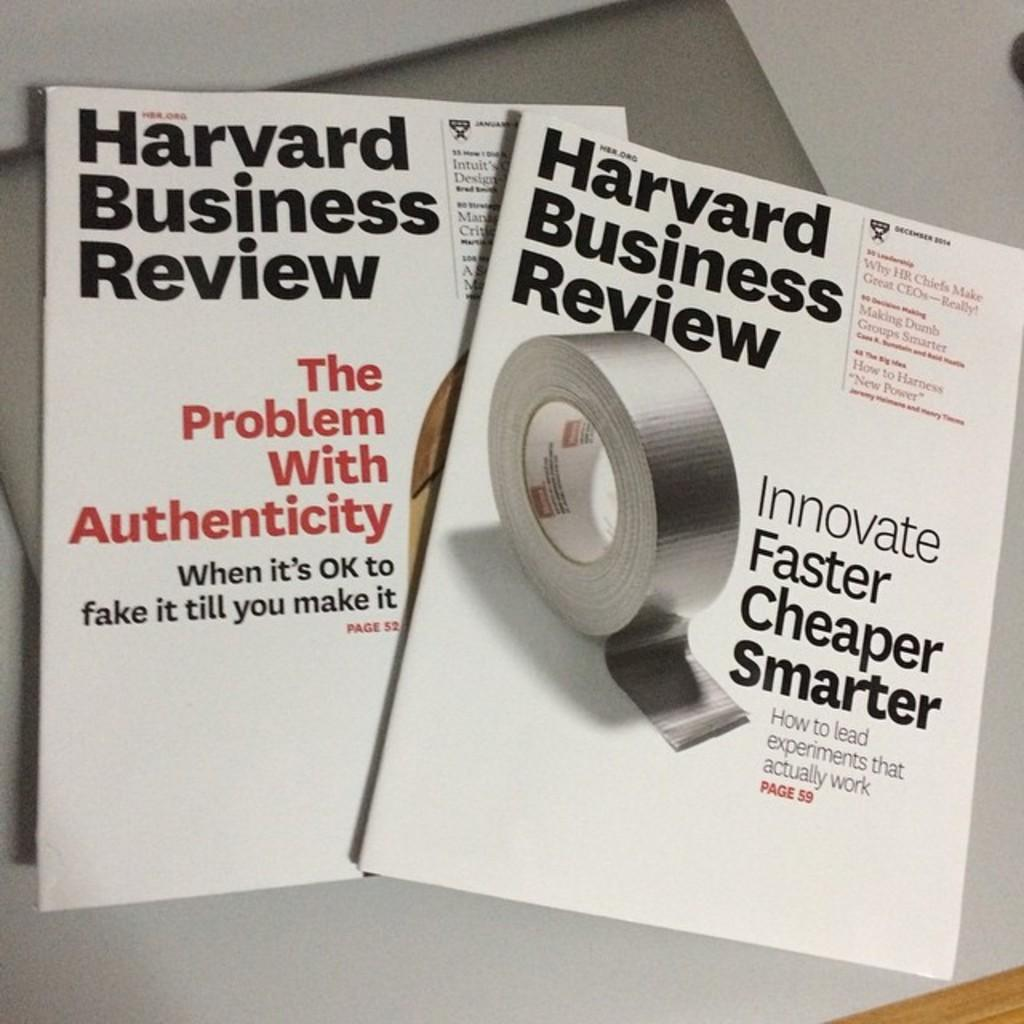<image>
Offer a succinct explanation of the picture presented. Two Harvard business review pamphlets sitting on a table. 